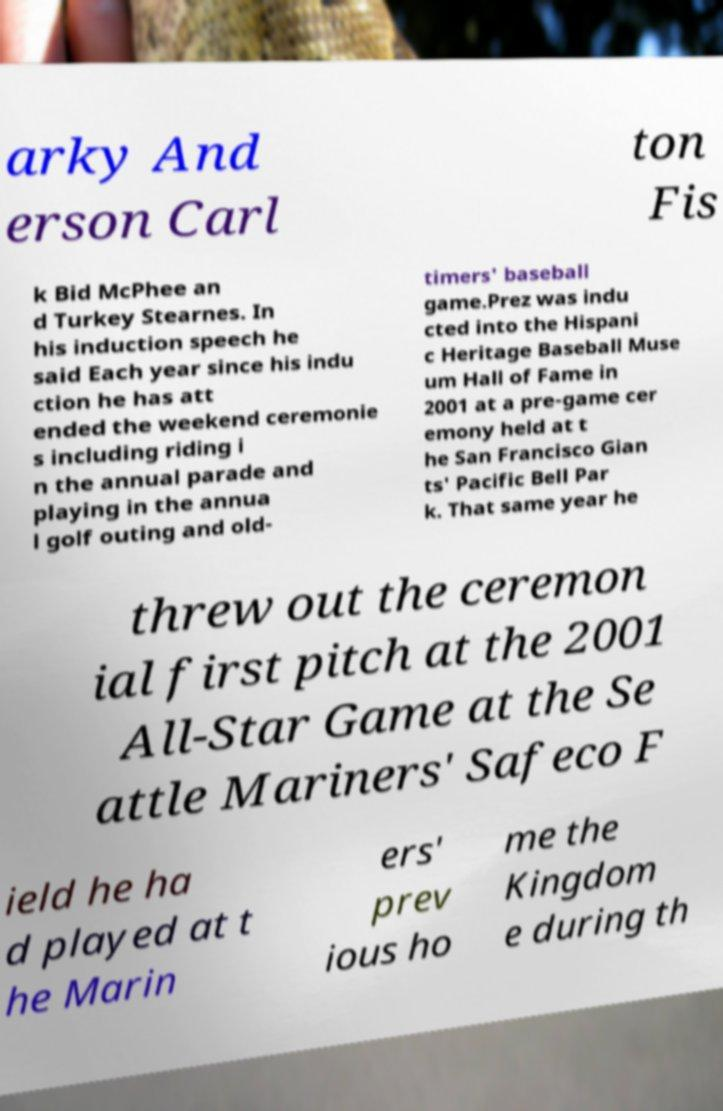Please identify and transcribe the text found in this image. arky And erson Carl ton Fis k Bid McPhee an d Turkey Stearnes. In his induction speech he said Each year since his indu ction he has att ended the weekend ceremonie s including riding i n the annual parade and playing in the annua l golf outing and old- timers' baseball game.Prez was indu cted into the Hispani c Heritage Baseball Muse um Hall of Fame in 2001 at a pre-game cer emony held at t he San Francisco Gian ts' Pacific Bell Par k. That same year he threw out the ceremon ial first pitch at the 2001 All-Star Game at the Se attle Mariners' Safeco F ield he ha d played at t he Marin ers' prev ious ho me the Kingdom e during th 